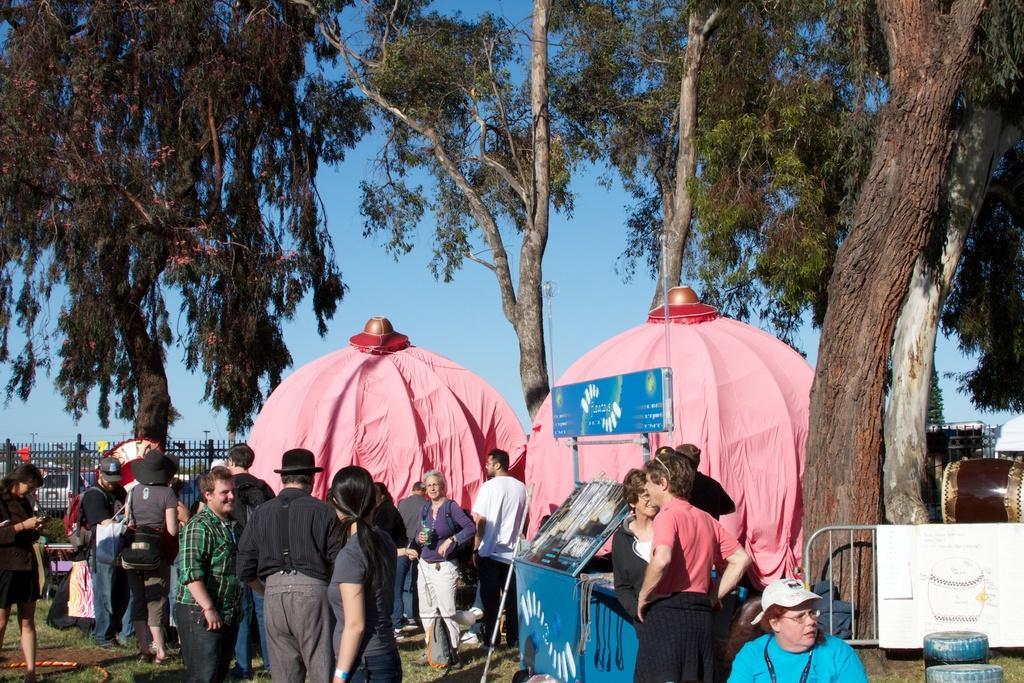Could you give a brief overview of what you see in this image? In the foreground of the image we can see some people are talking with each other and some of them are doing their work. In the middle of the image we can see two tents. On the top of the image we can see trees and the sky. 